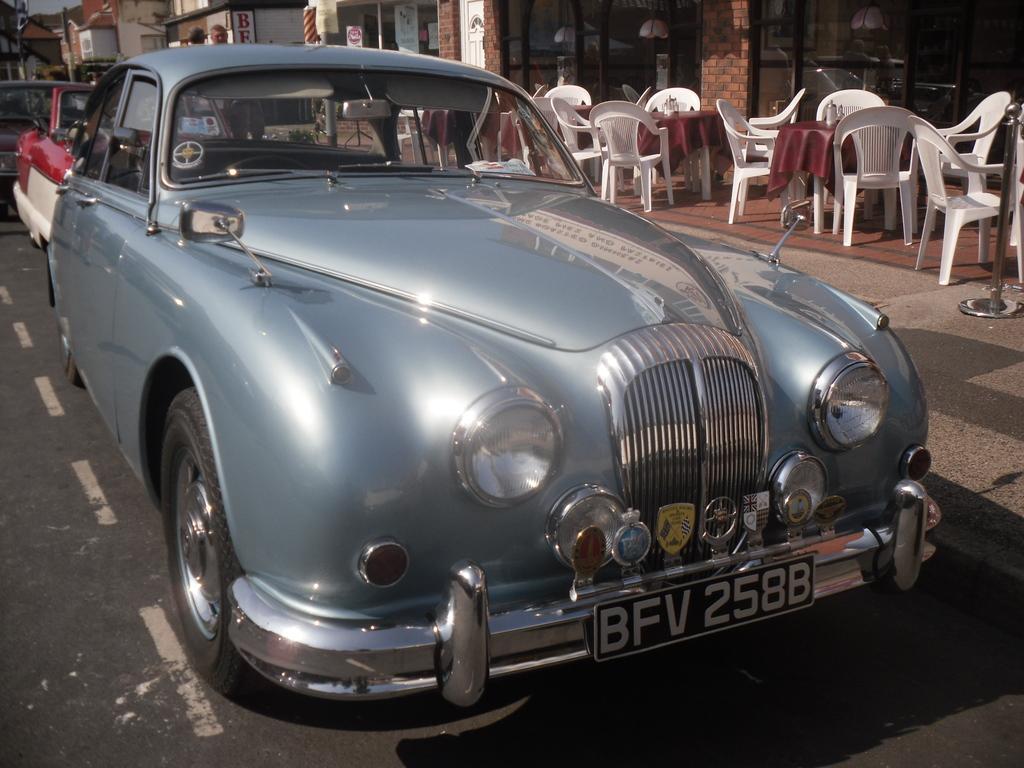Can you describe this image briefly? In this picture there is a car. There are chairs and a table. At the background there is a building. There is a person standing. 